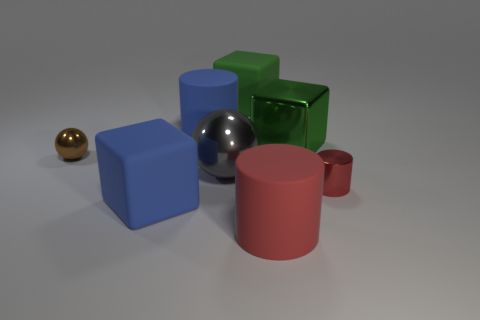Add 2 large metallic cylinders. How many objects exist? 10 Subtract all balls. How many objects are left? 6 Add 2 big spheres. How many big spheres are left? 3 Add 6 large blue rubber cylinders. How many large blue rubber cylinders exist? 7 Subtract 0 cyan balls. How many objects are left? 8 Subtract all small green cubes. Subtract all metallic cylinders. How many objects are left? 7 